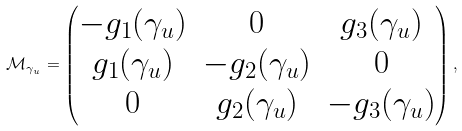Convert formula to latex. <formula><loc_0><loc_0><loc_500><loc_500>\mathcal { M } _ { \gamma _ { u } } = \begin{pmatrix} - g _ { 1 } ( \gamma _ { u } ) & 0 & g _ { 3 } ( \gamma _ { u } ) \\ g _ { 1 } ( \gamma _ { u } ) & - g _ { 2 } ( \gamma _ { u } ) & 0 \\ 0 & g _ { 2 } ( \gamma _ { u } ) & - g _ { 3 } ( \gamma _ { u } ) \end{pmatrix} ,</formula> 